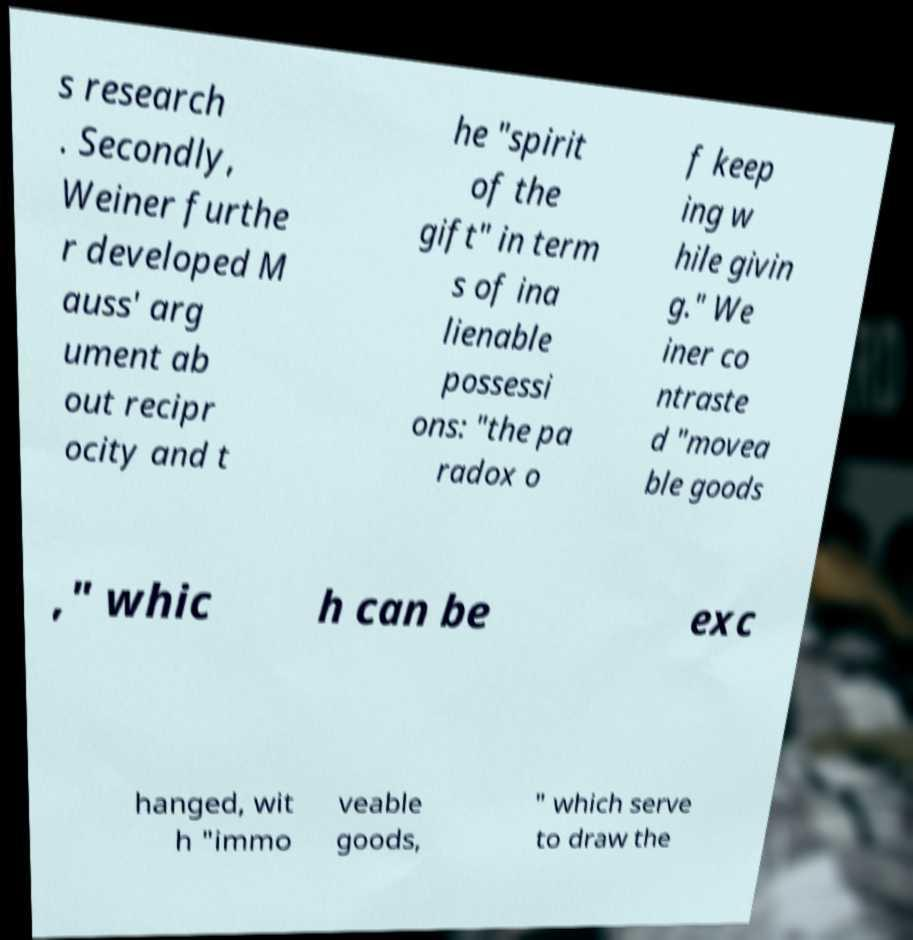Please read and relay the text visible in this image. What does it say? s research . Secondly, Weiner furthe r developed M auss' arg ument ab out recipr ocity and t he "spirit of the gift" in term s of ina lienable possessi ons: "the pa radox o f keep ing w hile givin g." We iner co ntraste d "movea ble goods ," whic h can be exc hanged, wit h "immo veable goods, " which serve to draw the 